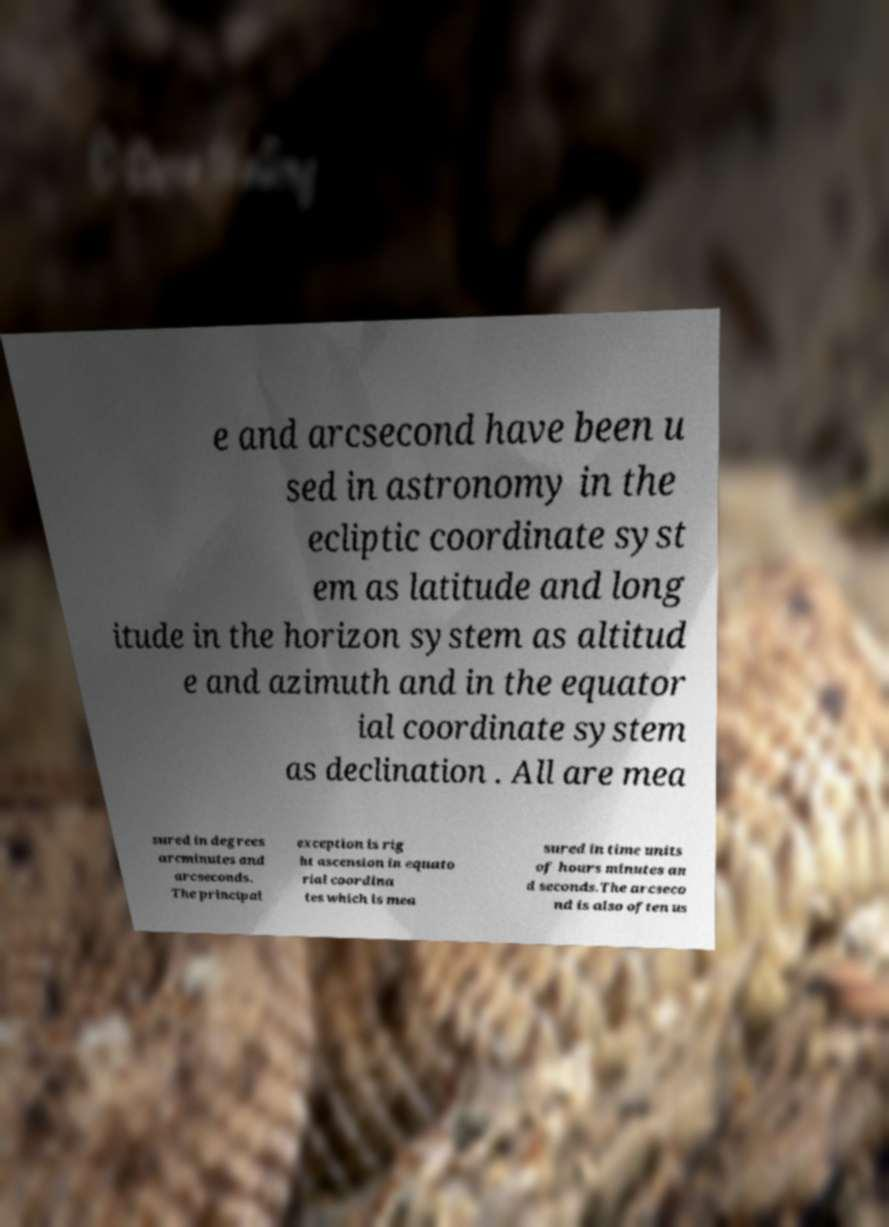Could you extract and type out the text from this image? e and arcsecond have been u sed in astronomy in the ecliptic coordinate syst em as latitude and long itude in the horizon system as altitud e and azimuth and in the equator ial coordinate system as declination . All are mea sured in degrees arcminutes and arcseconds. The principal exception is rig ht ascension in equato rial coordina tes which is mea sured in time units of hours minutes an d seconds.The arcseco nd is also often us 